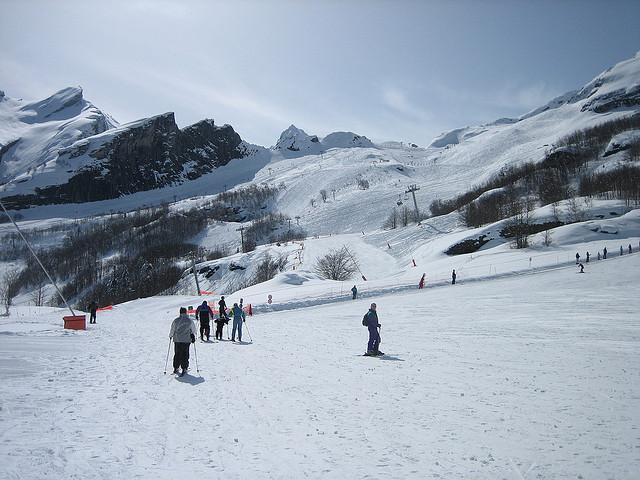What is the elevated metal railway called? ski lift 